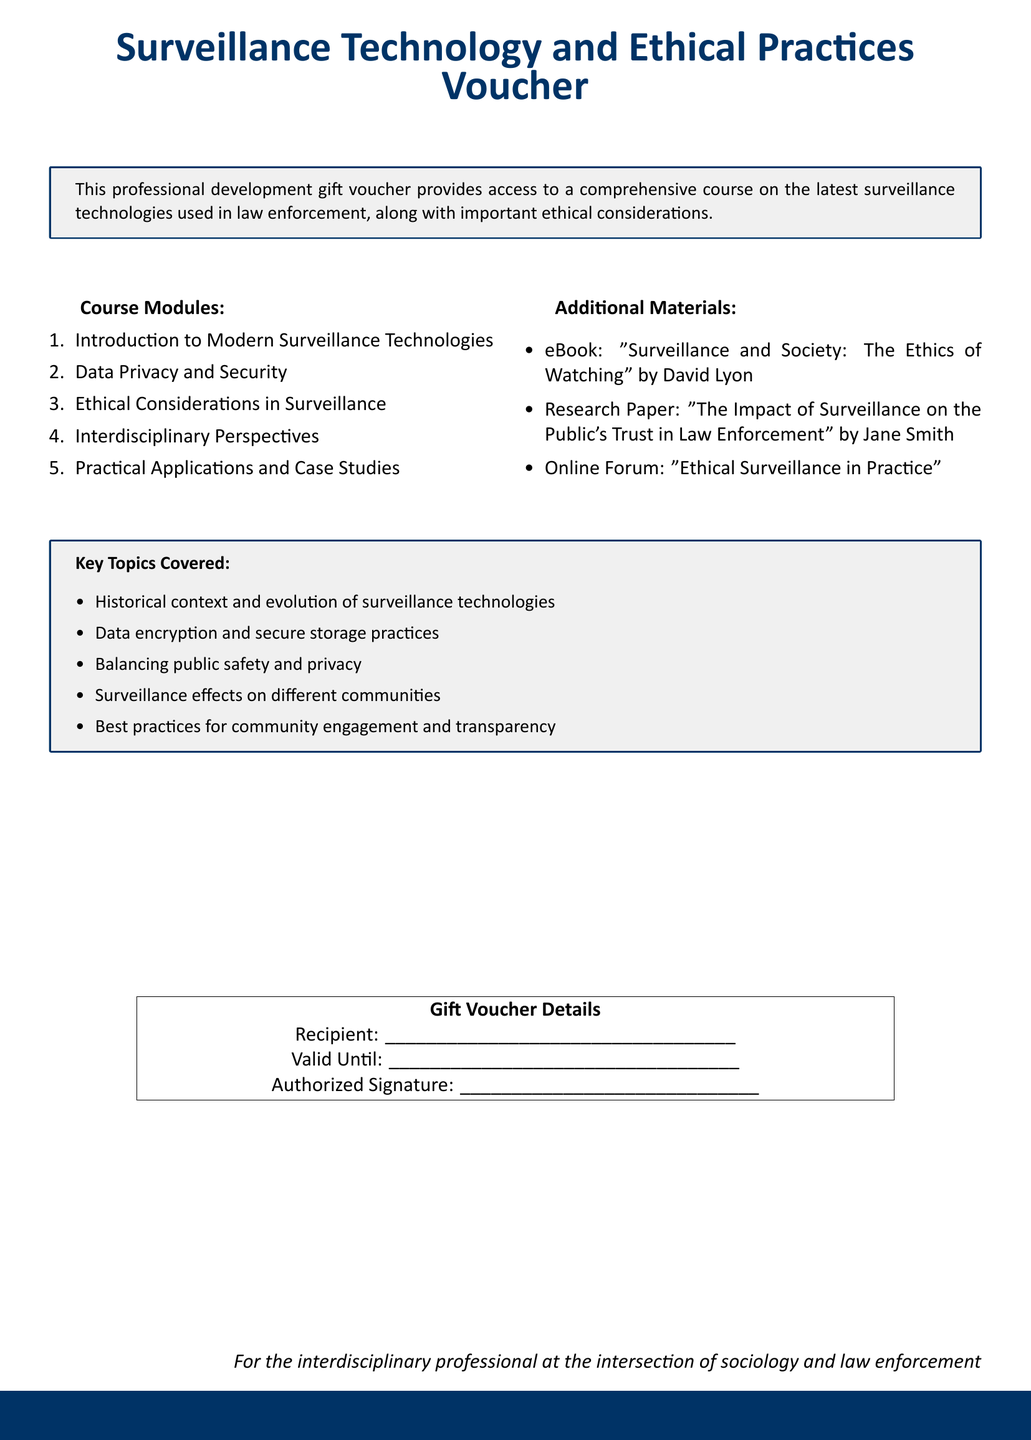What is the title of the course offered? The title of the course is presented at the top of the document, specifically focused on surveillance technologies and ethical practices.
Answer: Surveillance Technology and Ethical Practices Voucher How many course modules are listed? There is a specific count of the course modules included in the document, which states the total number clearly.
Answer: Five Who is the author of the eBook provided as additional material? The author of the eBook is mentioned in the additional materials section, detailing who wrote the book on surveillance and society.
Answer: David Lyon What is one key topic covered in the course? The document lists specific key topics, providing at least one example of what the course will cover regarding surveillance and ethical considerations.
Answer: Balancing public safety and privacy What is the purpose of this gift voucher? The purpose of the voucher is outlined in the introductory section, describing what it offers to the recipient regarding professional development.
Answer: Access to a comprehensive course What must be filled in the "Recipient" section? The document specifies that the recipient's name is to be filled in, which is a common practice for gift vouchers.
Answer: Recipient's name What type of courses does this voucher pertain to? The document indicates the broad subject matter to which the courses belong, specifically linking it to law enforcement practices.
Answer: Surveillance technologies What is provided as an additional material for the course? One of the items specified in the additional materials section can be obtained with the voucher, showcasing supplementary educational resources.
Answer: Research Paper: "The Impact of Surveillance on the Public's Trust in Law Enforcement" by Jane Smith 